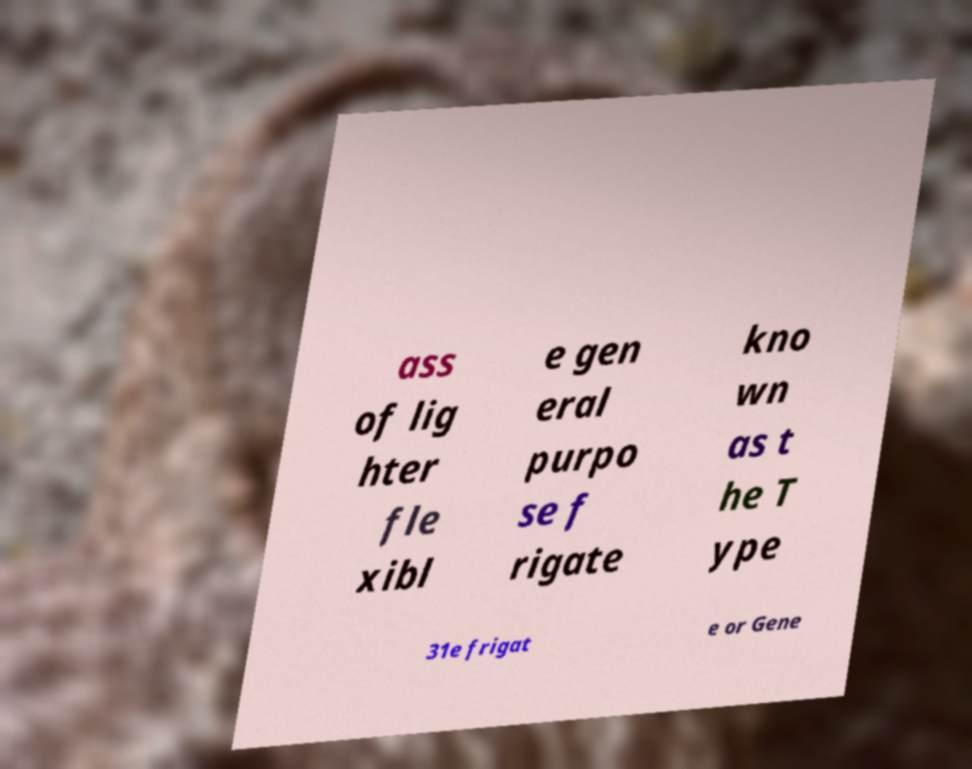Please read and relay the text visible in this image. What does it say? ass of lig hter fle xibl e gen eral purpo se f rigate kno wn as t he T ype 31e frigat e or Gene 